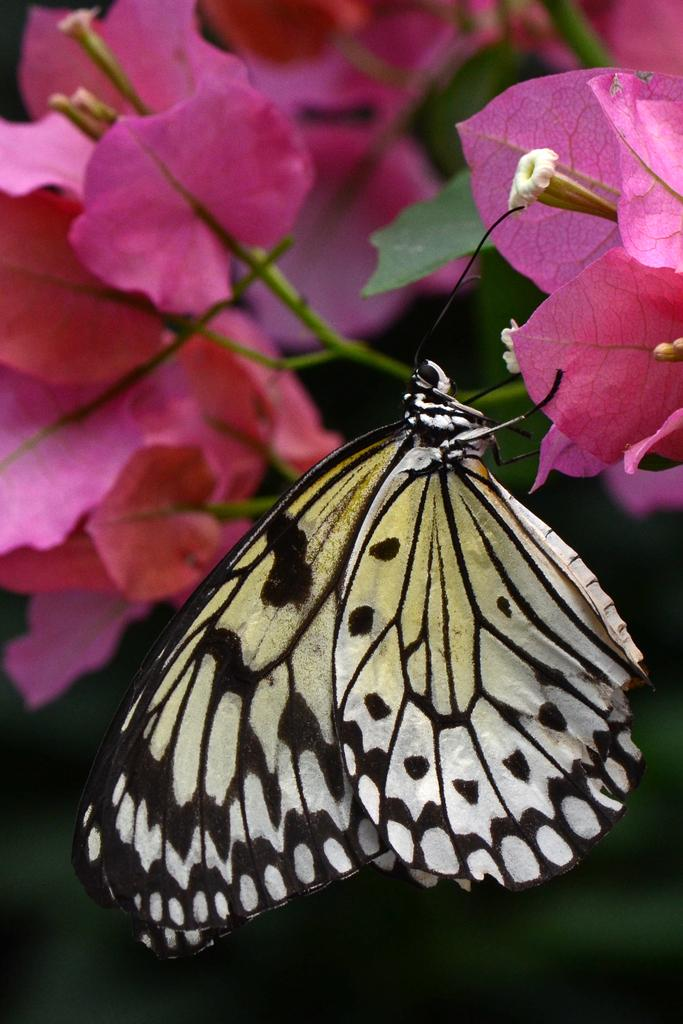What is the main subject of the image? There is a butterfly in the image. Where is the butterfly located? The butterfly is on a pink flower. What else can be seen in the image besides the butterfly? There are flowers visible in the background of the image. What type of mine is depicted in the image? There is no mine present in the image; it features a butterfly on a pink flower with flowers in the background. Can you tell me what the participants are discussing in the image? There are no participants or discussions present in the image; it features a butterfly on a pink flower with flowers in the background. 